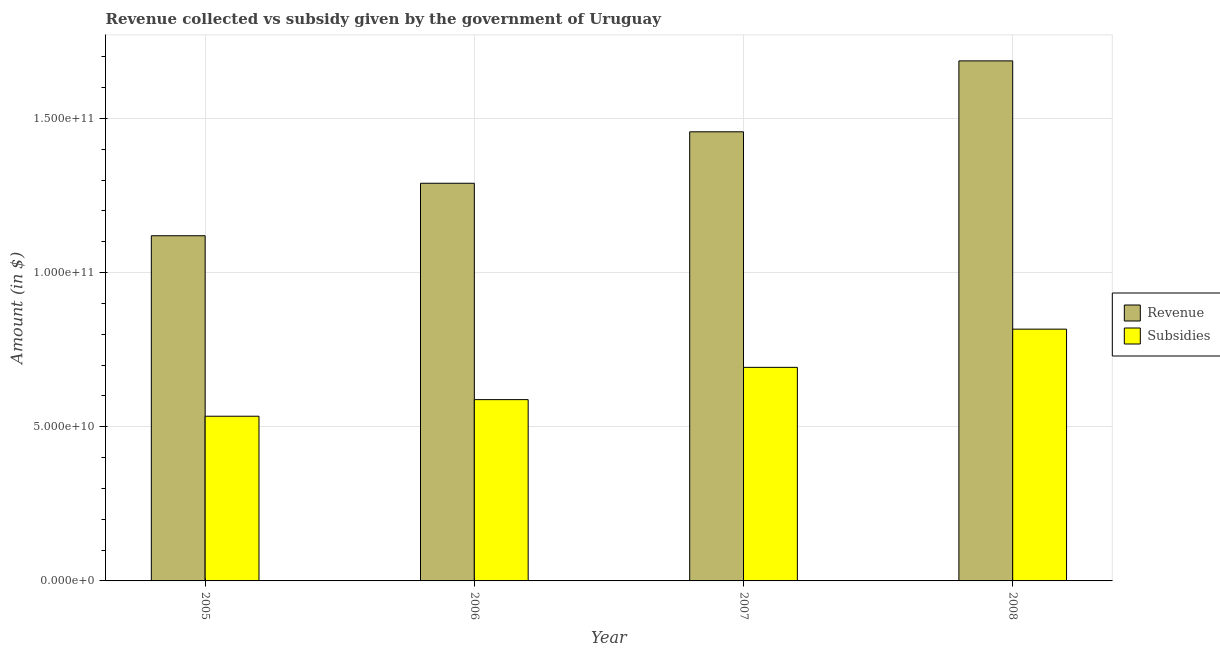How many different coloured bars are there?
Your answer should be very brief. 2. Are the number of bars per tick equal to the number of legend labels?
Keep it short and to the point. Yes. Are the number of bars on each tick of the X-axis equal?
Provide a succinct answer. Yes. What is the amount of subsidies given in 2006?
Provide a succinct answer. 5.88e+1. Across all years, what is the maximum amount of revenue collected?
Offer a terse response. 1.69e+11. Across all years, what is the minimum amount of revenue collected?
Make the answer very short. 1.12e+11. What is the total amount of revenue collected in the graph?
Offer a terse response. 5.55e+11. What is the difference between the amount of subsidies given in 2005 and that in 2006?
Offer a very short reply. -5.38e+09. What is the difference between the amount of subsidies given in 2006 and the amount of revenue collected in 2007?
Your answer should be very brief. -1.05e+1. What is the average amount of subsidies given per year?
Your answer should be very brief. 6.58e+1. In how many years, is the amount of subsidies given greater than 40000000000 $?
Make the answer very short. 4. What is the ratio of the amount of subsidies given in 2005 to that in 2008?
Offer a very short reply. 0.65. Is the difference between the amount of subsidies given in 2005 and 2007 greater than the difference between the amount of revenue collected in 2005 and 2007?
Ensure brevity in your answer.  No. What is the difference between the highest and the second highest amount of revenue collected?
Your answer should be compact. 2.30e+1. What is the difference between the highest and the lowest amount of subsidies given?
Make the answer very short. 2.82e+1. Is the sum of the amount of subsidies given in 2006 and 2007 greater than the maximum amount of revenue collected across all years?
Offer a terse response. Yes. What does the 1st bar from the left in 2006 represents?
Keep it short and to the point. Revenue. What does the 2nd bar from the right in 2008 represents?
Offer a terse response. Revenue. How many bars are there?
Offer a very short reply. 8. Are all the bars in the graph horizontal?
Your answer should be compact. No. Are the values on the major ticks of Y-axis written in scientific E-notation?
Your answer should be very brief. Yes. Does the graph contain any zero values?
Keep it short and to the point. No. Where does the legend appear in the graph?
Your response must be concise. Center right. How many legend labels are there?
Your answer should be compact. 2. What is the title of the graph?
Offer a very short reply. Revenue collected vs subsidy given by the government of Uruguay. Does "Largest city" appear as one of the legend labels in the graph?
Make the answer very short. No. What is the label or title of the X-axis?
Give a very brief answer. Year. What is the label or title of the Y-axis?
Your answer should be very brief. Amount (in $). What is the Amount (in $) in Revenue in 2005?
Your answer should be very brief. 1.12e+11. What is the Amount (in $) in Subsidies in 2005?
Provide a short and direct response. 5.34e+1. What is the Amount (in $) in Revenue in 2006?
Your response must be concise. 1.29e+11. What is the Amount (in $) of Subsidies in 2006?
Provide a succinct answer. 5.88e+1. What is the Amount (in $) of Revenue in 2007?
Make the answer very short. 1.46e+11. What is the Amount (in $) of Subsidies in 2007?
Give a very brief answer. 6.93e+1. What is the Amount (in $) in Revenue in 2008?
Your response must be concise. 1.69e+11. What is the Amount (in $) in Subsidies in 2008?
Offer a terse response. 8.17e+1. Across all years, what is the maximum Amount (in $) of Revenue?
Provide a short and direct response. 1.69e+11. Across all years, what is the maximum Amount (in $) in Subsidies?
Your answer should be very brief. 8.17e+1. Across all years, what is the minimum Amount (in $) in Revenue?
Provide a succinct answer. 1.12e+11. Across all years, what is the minimum Amount (in $) in Subsidies?
Ensure brevity in your answer.  5.34e+1. What is the total Amount (in $) in Revenue in the graph?
Ensure brevity in your answer.  5.55e+11. What is the total Amount (in $) in Subsidies in the graph?
Your answer should be very brief. 2.63e+11. What is the difference between the Amount (in $) in Revenue in 2005 and that in 2006?
Ensure brevity in your answer.  -1.70e+1. What is the difference between the Amount (in $) in Subsidies in 2005 and that in 2006?
Your response must be concise. -5.38e+09. What is the difference between the Amount (in $) in Revenue in 2005 and that in 2007?
Provide a short and direct response. -3.37e+1. What is the difference between the Amount (in $) of Subsidies in 2005 and that in 2007?
Your answer should be very brief. -1.58e+1. What is the difference between the Amount (in $) of Revenue in 2005 and that in 2008?
Offer a very short reply. -5.67e+1. What is the difference between the Amount (in $) in Subsidies in 2005 and that in 2008?
Keep it short and to the point. -2.82e+1. What is the difference between the Amount (in $) of Revenue in 2006 and that in 2007?
Provide a succinct answer. -1.67e+1. What is the difference between the Amount (in $) of Subsidies in 2006 and that in 2007?
Ensure brevity in your answer.  -1.05e+1. What is the difference between the Amount (in $) of Revenue in 2006 and that in 2008?
Provide a short and direct response. -3.97e+1. What is the difference between the Amount (in $) of Subsidies in 2006 and that in 2008?
Make the answer very short. -2.29e+1. What is the difference between the Amount (in $) in Revenue in 2007 and that in 2008?
Provide a succinct answer. -2.30e+1. What is the difference between the Amount (in $) of Subsidies in 2007 and that in 2008?
Make the answer very short. -1.24e+1. What is the difference between the Amount (in $) in Revenue in 2005 and the Amount (in $) in Subsidies in 2006?
Your answer should be compact. 5.32e+1. What is the difference between the Amount (in $) in Revenue in 2005 and the Amount (in $) in Subsidies in 2007?
Keep it short and to the point. 4.27e+1. What is the difference between the Amount (in $) of Revenue in 2005 and the Amount (in $) of Subsidies in 2008?
Ensure brevity in your answer.  3.03e+1. What is the difference between the Amount (in $) in Revenue in 2006 and the Amount (in $) in Subsidies in 2007?
Offer a very short reply. 5.97e+1. What is the difference between the Amount (in $) in Revenue in 2006 and the Amount (in $) in Subsidies in 2008?
Give a very brief answer. 4.73e+1. What is the difference between the Amount (in $) in Revenue in 2007 and the Amount (in $) in Subsidies in 2008?
Your response must be concise. 6.40e+1. What is the average Amount (in $) in Revenue per year?
Provide a short and direct response. 1.39e+11. What is the average Amount (in $) of Subsidies per year?
Give a very brief answer. 6.58e+1. In the year 2005, what is the difference between the Amount (in $) in Revenue and Amount (in $) in Subsidies?
Offer a very short reply. 5.85e+1. In the year 2006, what is the difference between the Amount (in $) in Revenue and Amount (in $) in Subsidies?
Your answer should be very brief. 7.02e+1. In the year 2007, what is the difference between the Amount (in $) in Revenue and Amount (in $) in Subsidies?
Ensure brevity in your answer.  7.64e+1. In the year 2008, what is the difference between the Amount (in $) of Revenue and Amount (in $) of Subsidies?
Provide a succinct answer. 8.70e+1. What is the ratio of the Amount (in $) in Revenue in 2005 to that in 2006?
Your answer should be compact. 0.87. What is the ratio of the Amount (in $) of Subsidies in 2005 to that in 2006?
Provide a succinct answer. 0.91. What is the ratio of the Amount (in $) of Revenue in 2005 to that in 2007?
Give a very brief answer. 0.77. What is the ratio of the Amount (in $) of Subsidies in 2005 to that in 2007?
Your response must be concise. 0.77. What is the ratio of the Amount (in $) of Revenue in 2005 to that in 2008?
Make the answer very short. 0.66. What is the ratio of the Amount (in $) of Subsidies in 2005 to that in 2008?
Offer a terse response. 0.65. What is the ratio of the Amount (in $) of Revenue in 2006 to that in 2007?
Provide a short and direct response. 0.89. What is the ratio of the Amount (in $) in Subsidies in 2006 to that in 2007?
Provide a succinct answer. 0.85. What is the ratio of the Amount (in $) in Revenue in 2006 to that in 2008?
Offer a terse response. 0.76. What is the ratio of the Amount (in $) in Subsidies in 2006 to that in 2008?
Your response must be concise. 0.72. What is the ratio of the Amount (in $) of Revenue in 2007 to that in 2008?
Offer a very short reply. 0.86. What is the ratio of the Amount (in $) of Subsidies in 2007 to that in 2008?
Provide a short and direct response. 0.85. What is the difference between the highest and the second highest Amount (in $) of Revenue?
Offer a terse response. 2.30e+1. What is the difference between the highest and the second highest Amount (in $) in Subsidies?
Offer a terse response. 1.24e+1. What is the difference between the highest and the lowest Amount (in $) in Revenue?
Your answer should be compact. 5.67e+1. What is the difference between the highest and the lowest Amount (in $) of Subsidies?
Make the answer very short. 2.82e+1. 